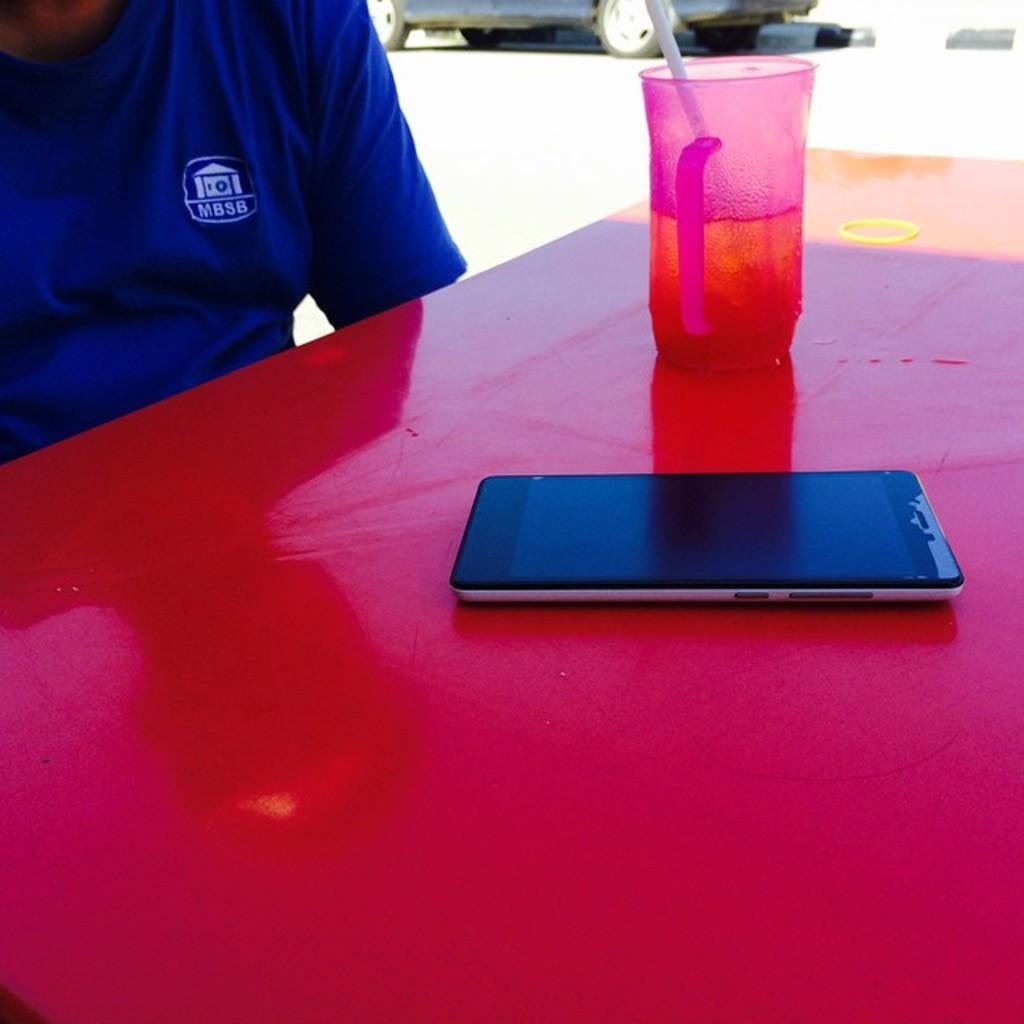How would you summarize this image in a sentence or two? On the red table there is a mobile and a glass. Inside the glass we can see a straw. To the left top corner there is a man sitting with blue color t-shirt. And we can also see a vehicle on the road. 